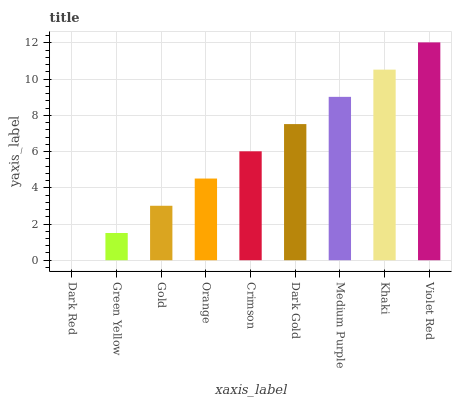Is Dark Red the minimum?
Answer yes or no. Yes. Is Violet Red the maximum?
Answer yes or no. Yes. Is Green Yellow the minimum?
Answer yes or no. No. Is Green Yellow the maximum?
Answer yes or no. No. Is Green Yellow greater than Dark Red?
Answer yes or no. Yes. Is Dark Red less than Green Yellow?
Answer yes or no. Yes. Is Dark Red greater than Green Yellow?
Answer yes or no. No. Is Green Yellow less than Dark Red?
Answer yes or no. No. Is Crimson the high median?
Answer yes or no. Yes. Is Crimson the low median?
Answer yes or no. Yes. Is Orange the high median?
Answer yes or no. No. Is Khaki the low median?
Answer yes or no. No. 